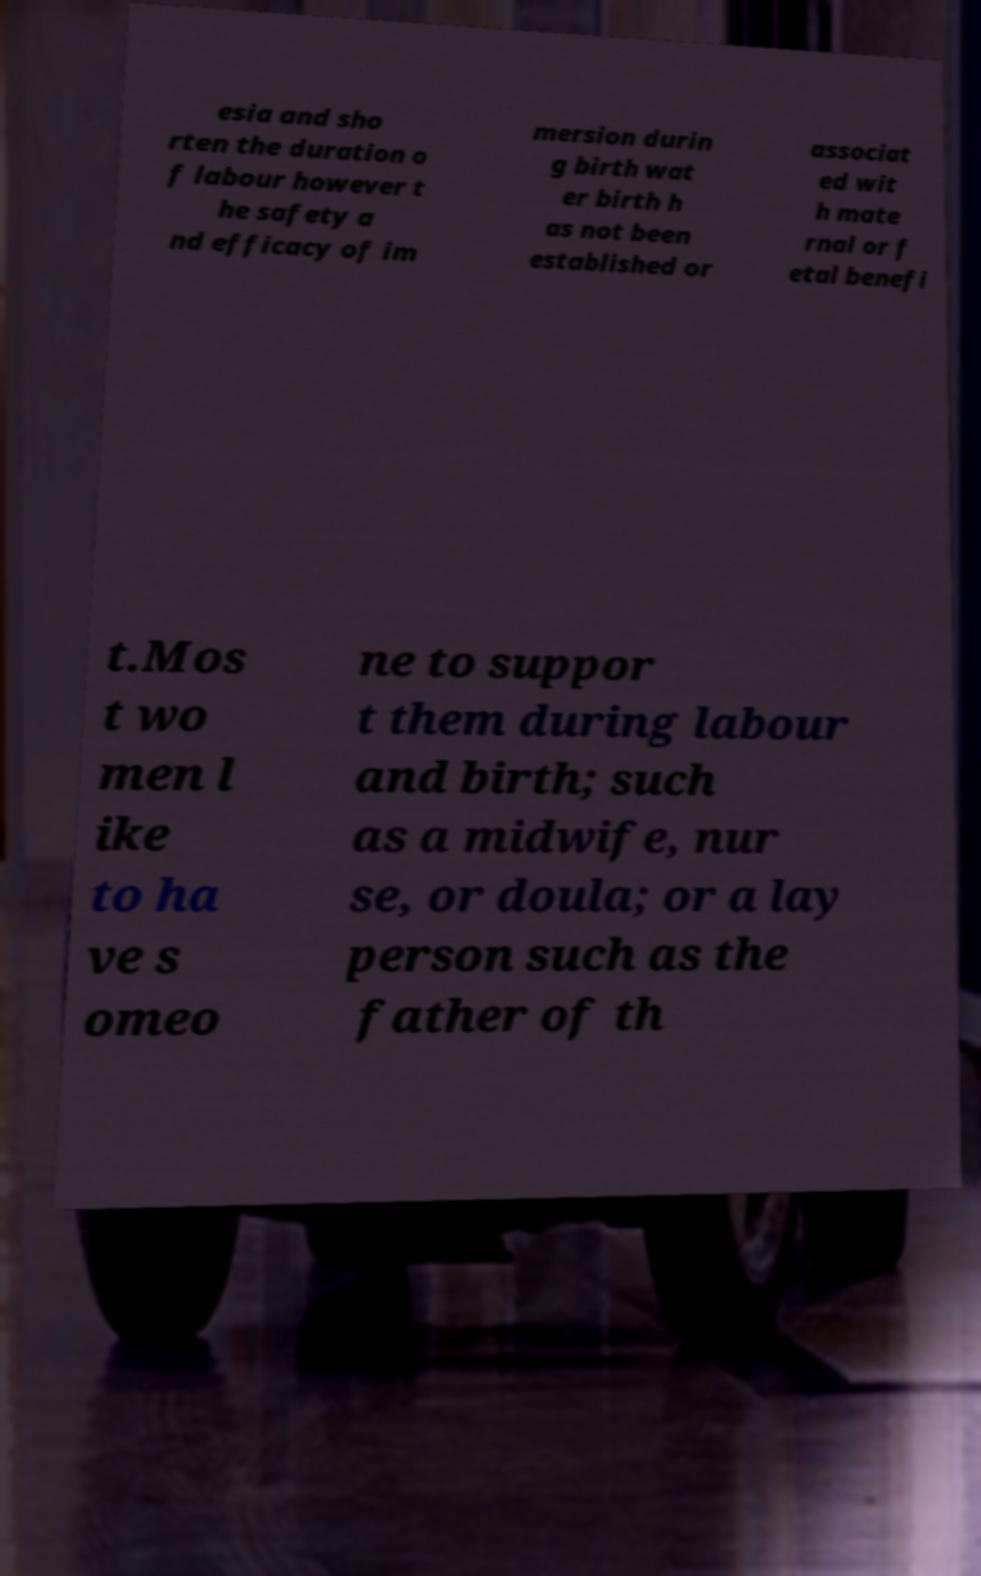There's text embedded in this image that I need extracted. Can you transcribe it verbatim? esia and sho rten the duration o f labour however t he safety a nd efficacy of im mersion durin g birth wat er birth h as not been established or associat ed wit h mate rnal or f etal benefi t.Mos t wo men l ike to ha ve s omeo ne to suppor t them during labour and birth; such as a midwife, nur se, or doula; or a lay person such as the father of th 